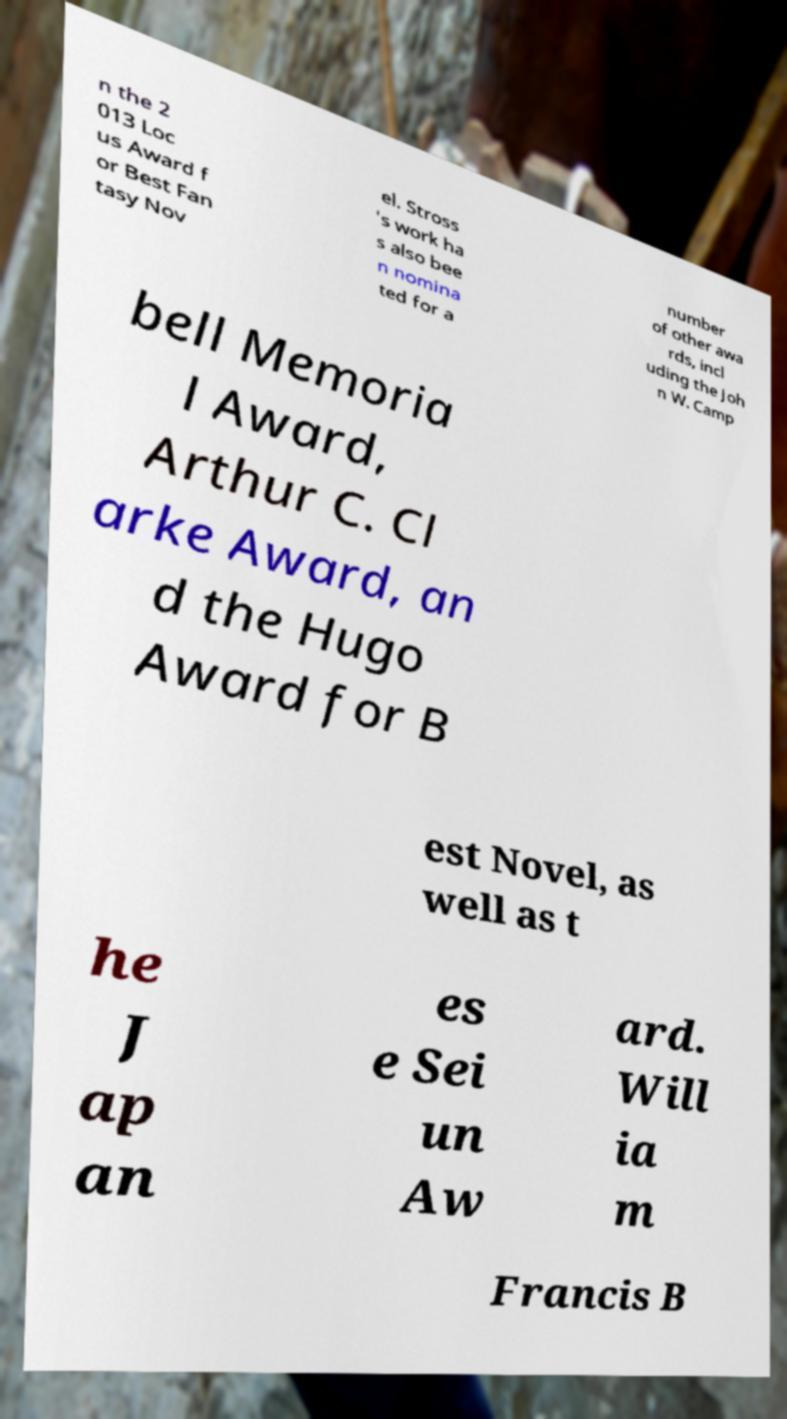Please read and relay the text visible in this image. What does it say? n the 2 013 Loc us Award f or Best Fan tasy Nov el. Stross 's work ha s also bee n nomina ted for a number of other awa rds, incl uding the Joh n W. Camp bell Memoria l Award, Arthur C. Cl arke Award, an d the Hugo Award for B est Novel, as well as t he J ap an es e Sei un Aw ard. Will ia m Francis B 